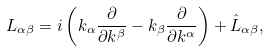Convert formula to latex. <formula><loc_0><loc_0><loc_500><loc_500>L _ { \alpha \beta } = i \left ( k _ { \alpha } \frac { \partial } { \partial k ^ { \beta } } - k _ { \beta } \frac { \partial } { \partial k ^ { \alpha } } \right ) + \hat { L } _ { \alpha \beta } ,</formula> 